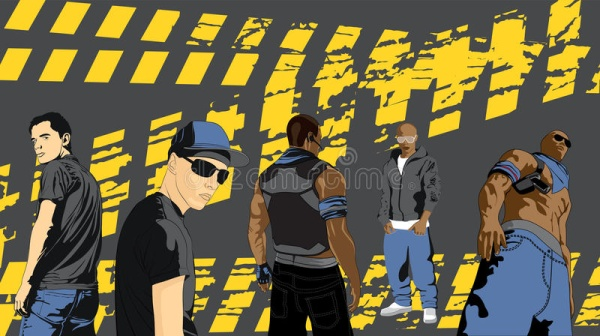What emotions do the men seem to be conveying? The men in the image appear to be conveying a variety of emotions that reflect confidence, mystery, assertiveness, casualness, and physical strength. The man on the far left, with his arms crossed, exudes confidence and firmness. The second man, with his direct gaze and sunglasses, portrays assertiveness. The man in the center, who has turned his back to the viewer, adds an element of mystery and contemplation. Meanwhile, the man next to him, with his hands in his pockets, appears to be laid-back and nonchalant. Finally, the man on the far right, flexing his muscles, showcases pride and strength. 